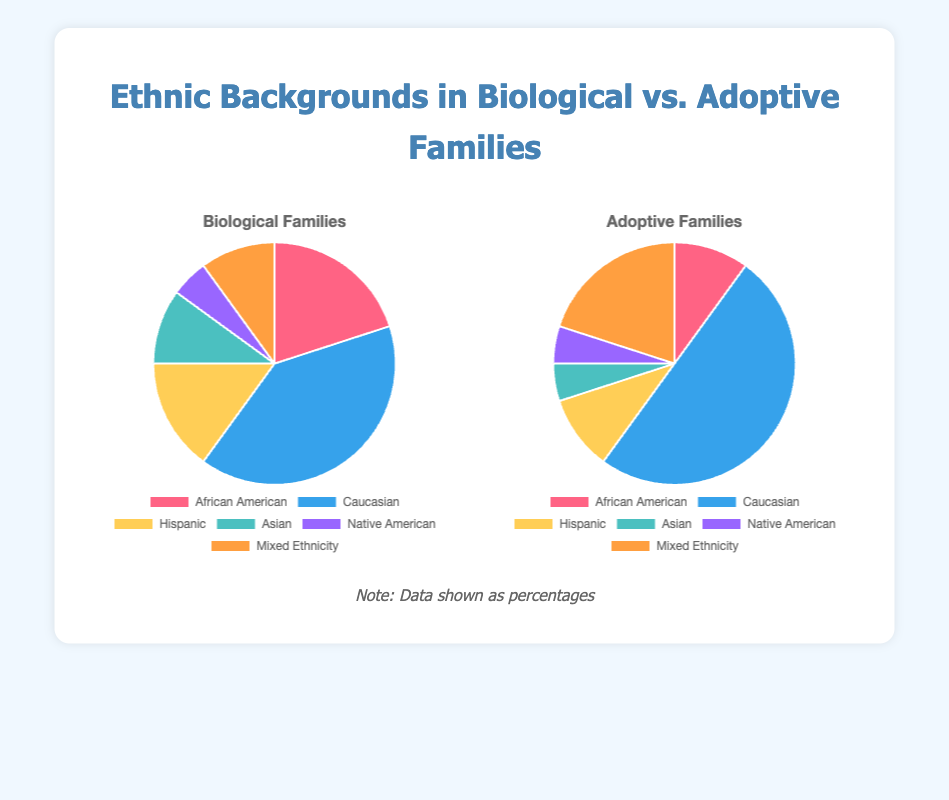What is the largest ethnic group in biological families? The largest ethnic group in biological families is represented by the largest slice on the biological families pie chart. By looking at the pie chart, the largest slice is labeled "Caucasian".
Answer: Caucasian Which ethnicities have the same percentage in both biological and adoptive families? To determine which ethnicities have the same percentage, we need to identify the slices that are identical in size and labeled similarly in both pie charts. Both "Native American" categories have the same percentage.
Answer: Native American How much more percentage do Caucasians have in adoptive families compared to biological families? The "Caucasian" slice in biological families represents 40%, and in adoptive families, it represents 50%. The difference is 50% - 40% = 10%.
Answer: 10% Which ethnic group has the most significant increase when comparing biological to adoptive families? By comparing the sizes of the slices between the pie charts, the most noticeable increase is in the "Mixed Ethnicity" category, increasing from 10% in biological families to 20% in adoptive families.
Answer: Mixed Ethnicity What percentage of adoptive families are of African American background? The slice labeled "African American" in the adoptive families pie chart represents 10% of the adoptive families.
Answer: 10% Is the proportion of Hispanic families higher in biological or adoptive families? Comparing the slices labeled "Hispanic" in both pie charts, the biological families chart shows 15% while the adoptive families chart shows 10%. Therefore, the proportion is higher in biological families.
Answer: Biological families Which ethnic group has the smallest representation in both biological and adoptive families? To identify the smallest representation, look for the smallest slices in both pie charts. "Native American" has the smallest representation, with 5% in both.
Answer: Native American What is the combined percentage of "Asian" and "Mixed Ethnicity" in biological families? In biological families, "Asian" is 10% and "Mixed Ethnicity" is 10%. Summing these gives 10% + 10% = 20%.
Answer: 20% What is the difference in the number of "Mixed Ethnicity" families between biological and adoptive families? In the biological families chart, "Mixed Ethnicity" is 10%. In the adoptive families chart, it is 20%. The difference is 20% - 10% = 10%. Although we cannot know the absolute numbers, the percentage difference is 10%.
Answer: 10% What color represents the "Caucasian" slice in the biological families chart? To identify the color, look at the chart and find the "Caucasian" label, which is represented by the light blue color.
Answer: Light blue 